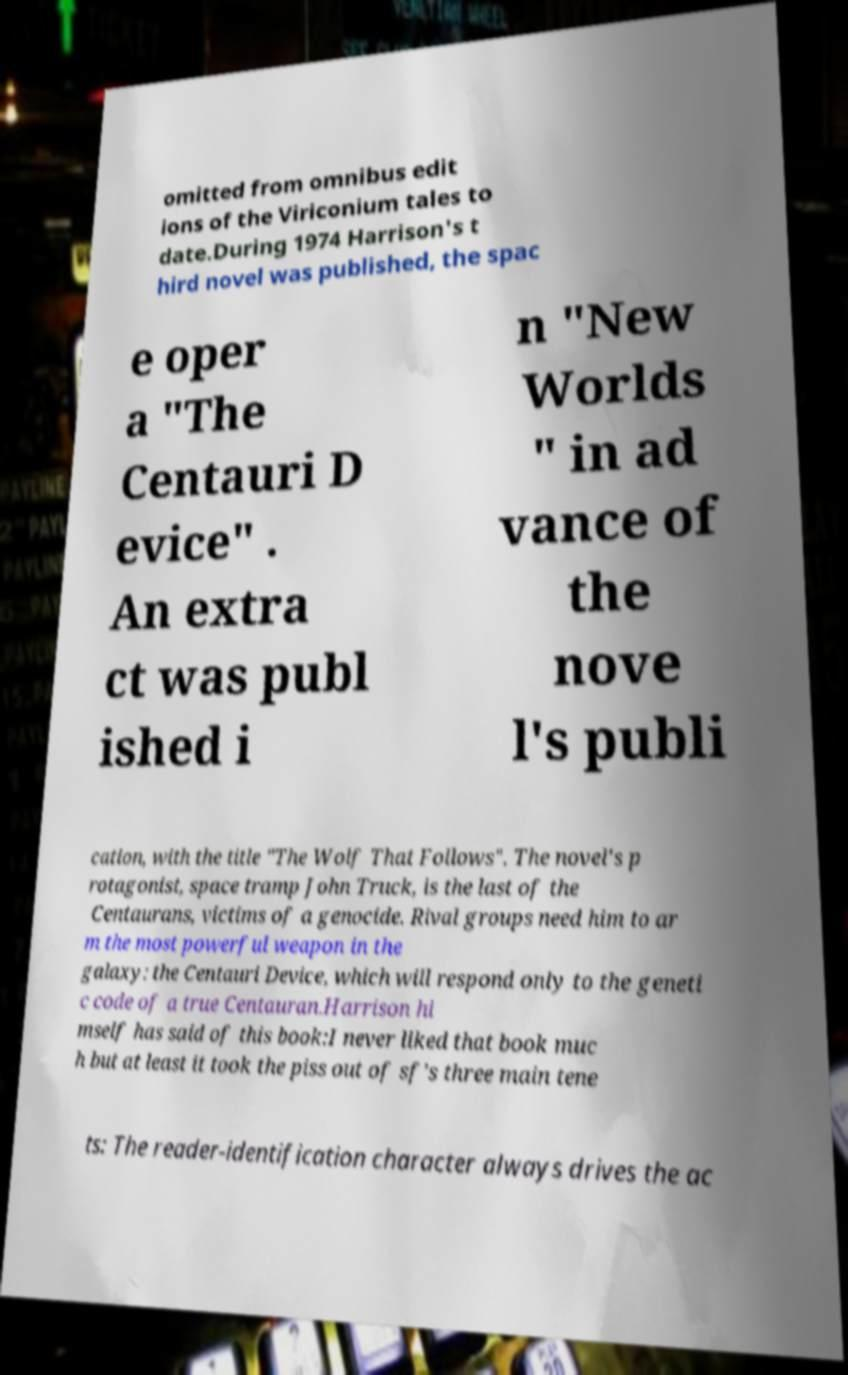What messages or text are displayed in this image? I need them in a readable, typed format. omitted from omnibus edit ions of the Viriconium tales to date.During 1974 Harrison's t hird novel was published, the spac e oper a "The Centauri D evice" . An extra ct was publ ished i n "New Worlds " in ad vance of the nove l's publi cation, with the title "The Wolf That Follows". The novel's p rotagonist, space tramp John Truck, is the last of the Centaurans, victims of a genocide. Rival groups need him to ar m the most powerful weapon in the galaxy: the Centauri Device, which will respond only to the geneti c code of a true Centauran.Harrison hi mself has said of this book:I never liked that book muc h but at least it took the piss out of sf’s three main tene ts: The reader-identification character always drives the ac 